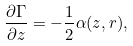Convert formula to latex. <formula><loc_0><loc_0><loc_500><loc_500>\frac { \partial \Gamma } { \partial z } = - \frac { 1 } { 2 } \alpha ( z , r ) ,</formula> 